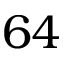Convert formula to latex. <formula><loc_0><loc_0><loc_500><loc_500>6 4</formula> 